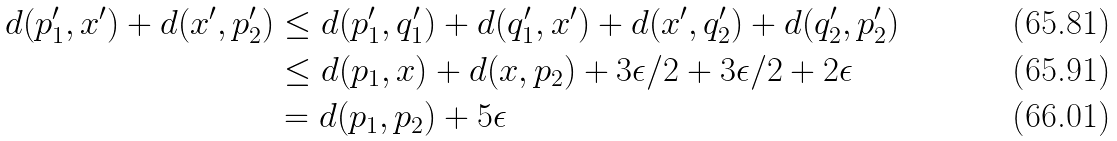Convert formula to latex. <formula><loc_0><loc_0><loc_500><loc_500>d ( p _ { 1 } ^ { \prime } , x ^ { \prime } ) + d ( x ^ { \prime } , p _ { 2 } ^ { \prime } ) & \leq d ( p _ { 1 } ^ { \prime } , q _ { 1 } ^ { \prime } ) + d ( q _ { 1 } ^ { \prime } , x ^ { \prime } ) + d ( x ^ { \prime } , q _ { 2 } ^ { \prime } ) + d ( q _ { 2 } ^ { \prime } , p _ { 2 } ^ { \prime } ) \\ & \leq d ( p _ { 1 } , x ) + d ( x , p _ { 2 } ) + 3 \epsilon / 2 + 3 \epsilon / 2 + 2 \epsilon \\ & = d ( p _ { 1 } , p _ { 2 } ) + 5 \epsilon</formula> 